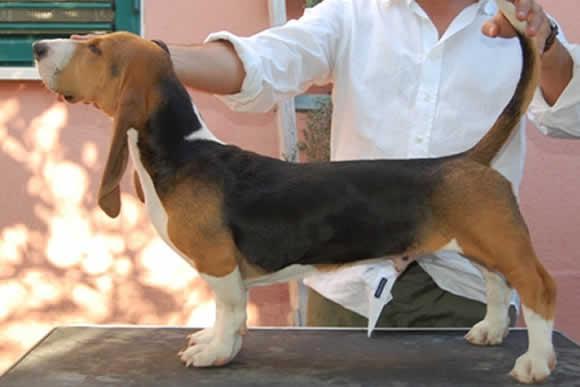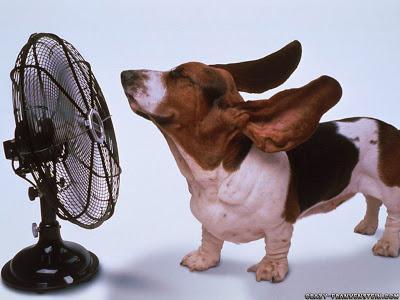The first image is the image on the left, the second image is the image on the right. Considering the images on both sides, is "Each image shows one standing basset hound, and one image includes a person with hands at the front and back of the dog." valid? Answer yes or no. Yes. The first image is the image on the left, the second image is the image on the right. Analyze the images presented: Is the assertion "there is a beagle outside on the grass" valid? Answer yes or no. No. 